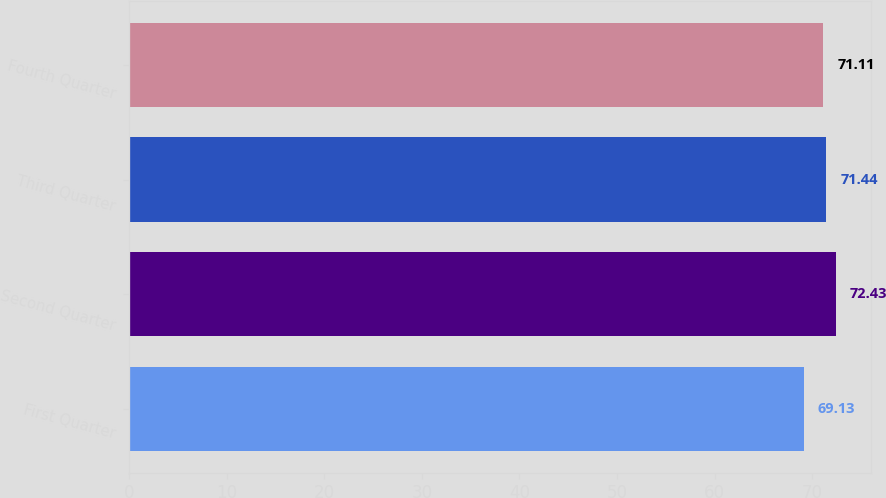<chart> <loc_0><loc_0><loc_500><loc_500><bar_chart><fcel>First Quarter<fcel>Second Quarter<fcel>Third Quarter<fcel>Fourth Quarter<nl><fcel>69.13<fcel>72.43<fcel>71.44<fcel>71.11<nl></chart> 